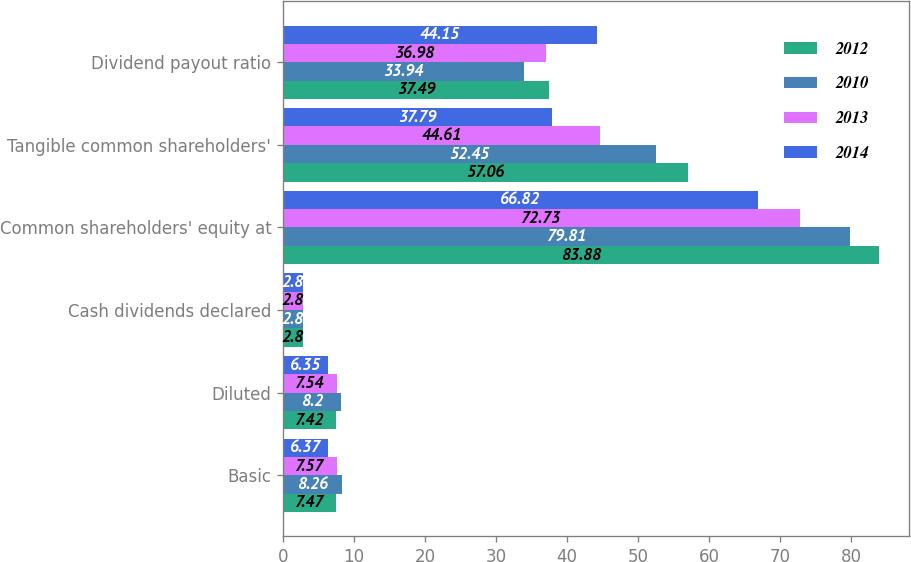Convert chart. <chart><loc_0><loc_0><loc_500><loc_500><stacked_bar_chart><ecel><fcel>Basic<fcel>Diluted<fcel>Cash dividends declared<fcel>Common shareholders' equity at<fcel>Tangible common shareholders'<fcel>Dividend payout ratio<nl><fcel>2012<fcel>7.47<fcel>7.42<fcel>2.8<fcel>83.88<fcel>57.06<fcel>37.49<nl><fcel>2010<fcel>8.26<fcel>8.2<fcel>2.8<fcel>79.81<fcel>52.45<fcel>33.94<nl><fcel>2013<fcel>7.57<fcel>7.54<fcel>2.8<fcel>72.73<fcel>44.61<fcel>36.98<nl><fcel>2014<fcel>6.37<fcel>6.35<fcel>2.8<fcel>66.82<fcel>37.79<fcel>44.15<nl></chart> 